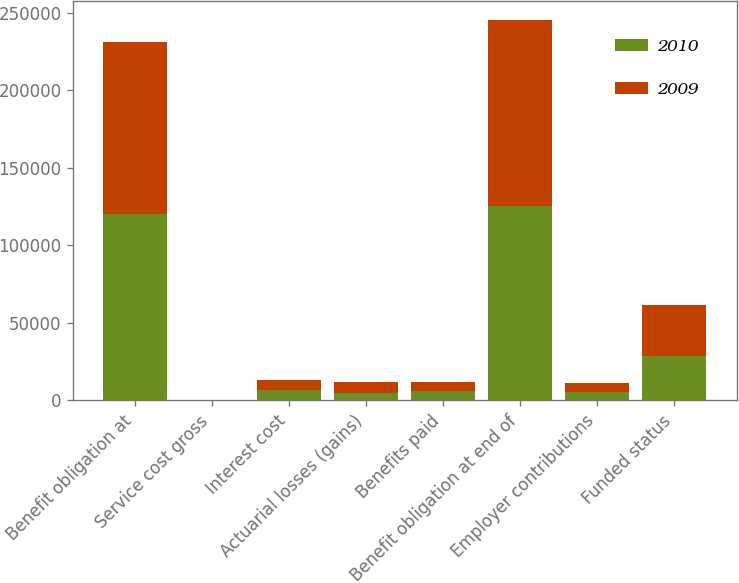<chart> <loc_0><loc_0><loc_500><loc_500><stacked_bar_chart><ecel><fcel>Benefit obligation at<fcel>Service cost gross<fcel>Interest cost<fcel>Actuarial losses (gains)<fcel>Benefits paid<fcel>Benefit obligation at end of<fcel>Employer contributions<fcel>Funded status<nl><fcel>2010<fcel>119930<fcel>264<fcel>6439<fcel>4661<fcel>5954<fcel>125340<fcel>5058<fcel>28300<nl><fcel>2009<fcel>111368<fcel>183<fcel>6782<fcel>7431<fcel>5834<fcel>119930<fcel>6045<fcel>33129<nl></chart> 